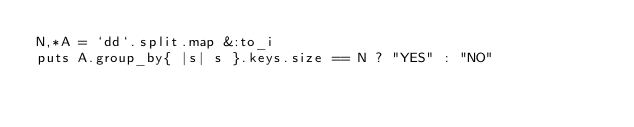<code> <loc_0><loc_0><loc_500><loc_500><_Ruby_>N,*A = `dd`.split.map &:to_i
puts A.group_by{ |s| s }.keys.size == N ? "YES" : "NO"</code> 